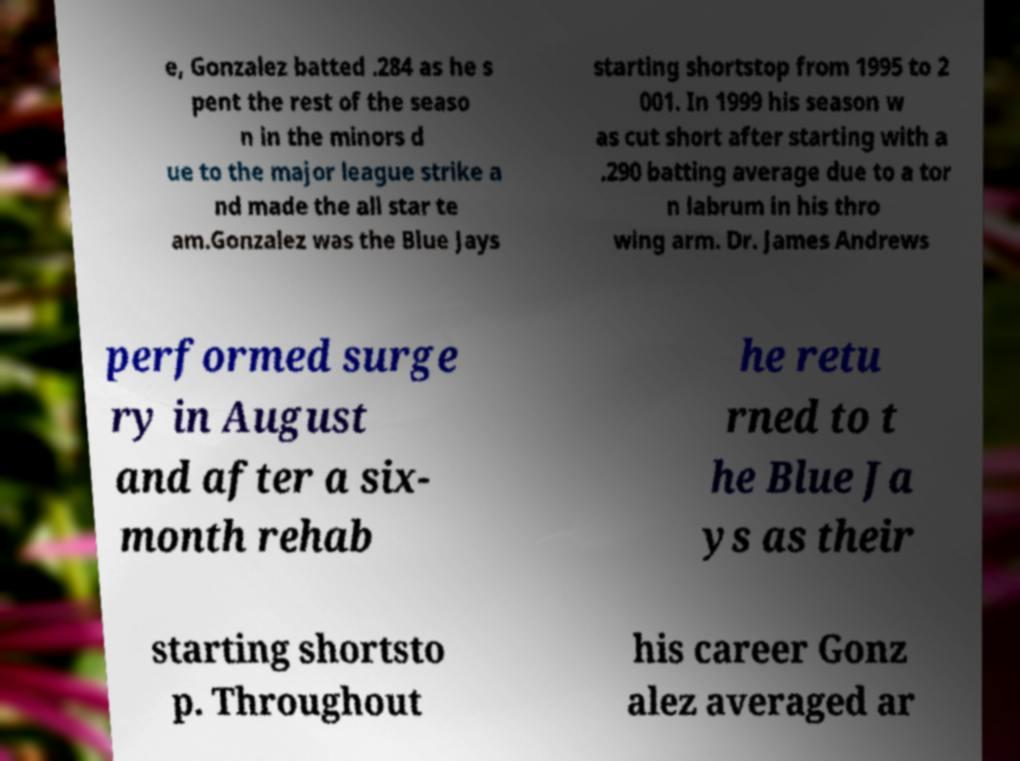I need the written content from this picture converted into text. Can you do that? e, Gonzalez batted .284 as he s pent the rest of the seaso n in the minors d ue to the major league strike a nd made the all star te am.Gonzalez was the Blue Jays starting shortstop from 1995 to 2 001. In 1999 his season w as cut short after starting with a .290 batting average due to a tor n labrum in his thro wing arm. Dr. James Andrews performed surge ry in August and after a six- month rehab he retu rned to t he Blue Ja ys as their starting shortsto p. Throughout his career Gonz alez averaged ar 